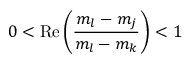<formula> <loc_0><loc_0><loc_500><loc_500>0 < R e \left ( \frac { m _ { l } - m _ { j } } { m _ { l } - m _ { k } } \right ) < 1</formula> 